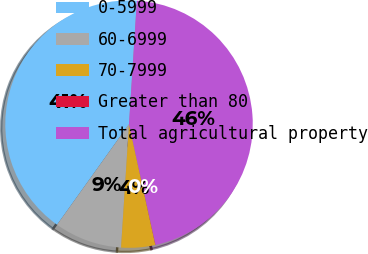Convert chart. <chart><loc_0><loc_0><loc_500><loc_500><pie_chart><fcel>0-5999<fcel>60-6999<fcel>70-7999<fcel>Greater than 80<fcel>Total agricultural property<nl><fcel>41.14%<fcel>8.85%<fcel>4.44%<fcel>0.04%<fcel>45.54%<nl></chart> 